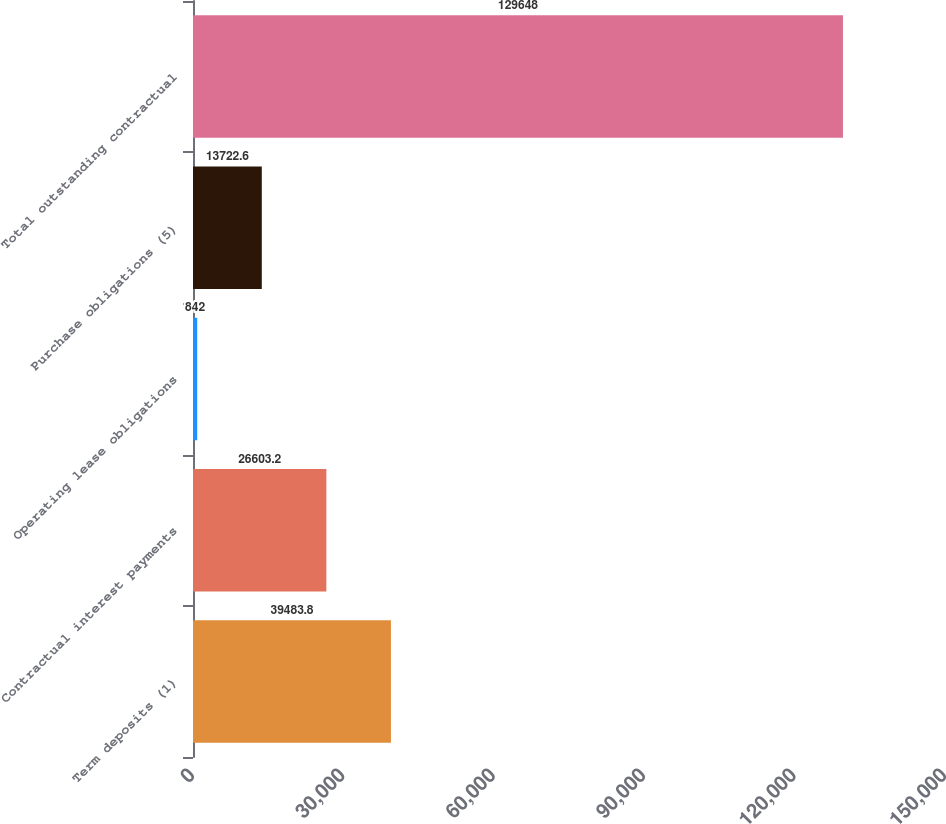Convert chart. <chart><loc_0><loc_0><loc_500><loc_500><bar_chart><fcel>Term deposits (1)<fcel>Contractual interest payments<fcel>Operating lease obligations<fcel>Purchase obligations (5)<fcel>Total outstanding contractual<nl><fcel>39483.8<fcel>26603.2<fcel>842<fcel>13722.6<fcel>129648<nl></chart> 